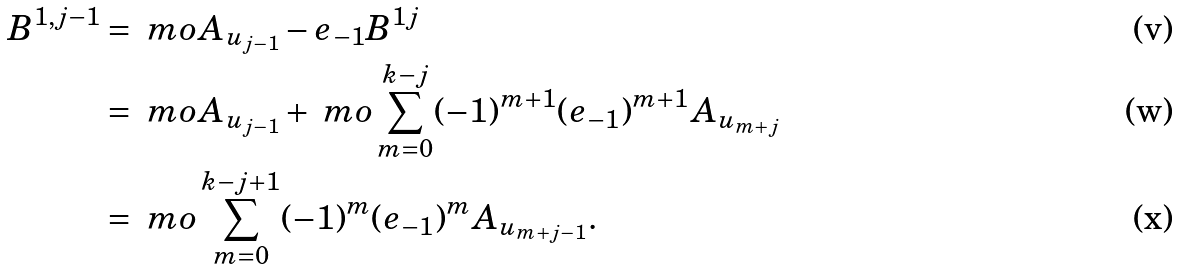Convert formula to latex. <formula><loc_0><loc_0><loc_500><loc_500>B ^ { 1 , j - 1 } & = \ m o A _ { u _ { j - 1 } } - e _ { - 1 } B ^ { 1 j } \\ & = \ m o A _ { u _ { j - 1 } } + \ m o \sum _ { m = 0 } ^ { k - j } ( - 1 ) ^ { m + 1 } ( e _ { - 1 } ) ^ { m + 1 } A _ { u _ { m + j } } \\ & = \ m o \sum _ { m = 0 } ^ { k - j + 1 } ( - 1 ) ^ { m } ( e _ { - 1 } ) ^ { m } A _ { u _ { m + j - 1 } } .</formula> 